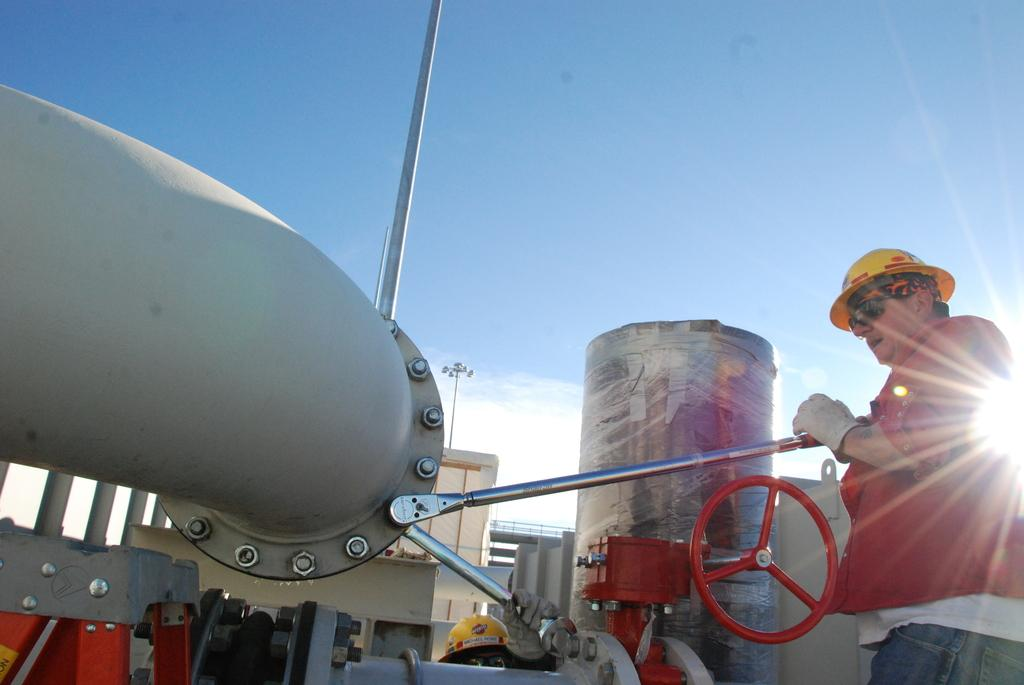What is the man in the image doing? The man is standing in the image and holding a rod. What protective gear is the man wearing? The man is wearing a helmet in the image. What type of eyewear is the man wearing? The man is wearing glasses in the image. What else can be seen in the image besides the man? There are machines and the sky visible in the image. What type of oven can be seen in the image? There is no oven present in the image. What test is the man conducting with the rod and machines in the image? The image does not provide information about any tests being conducted. 